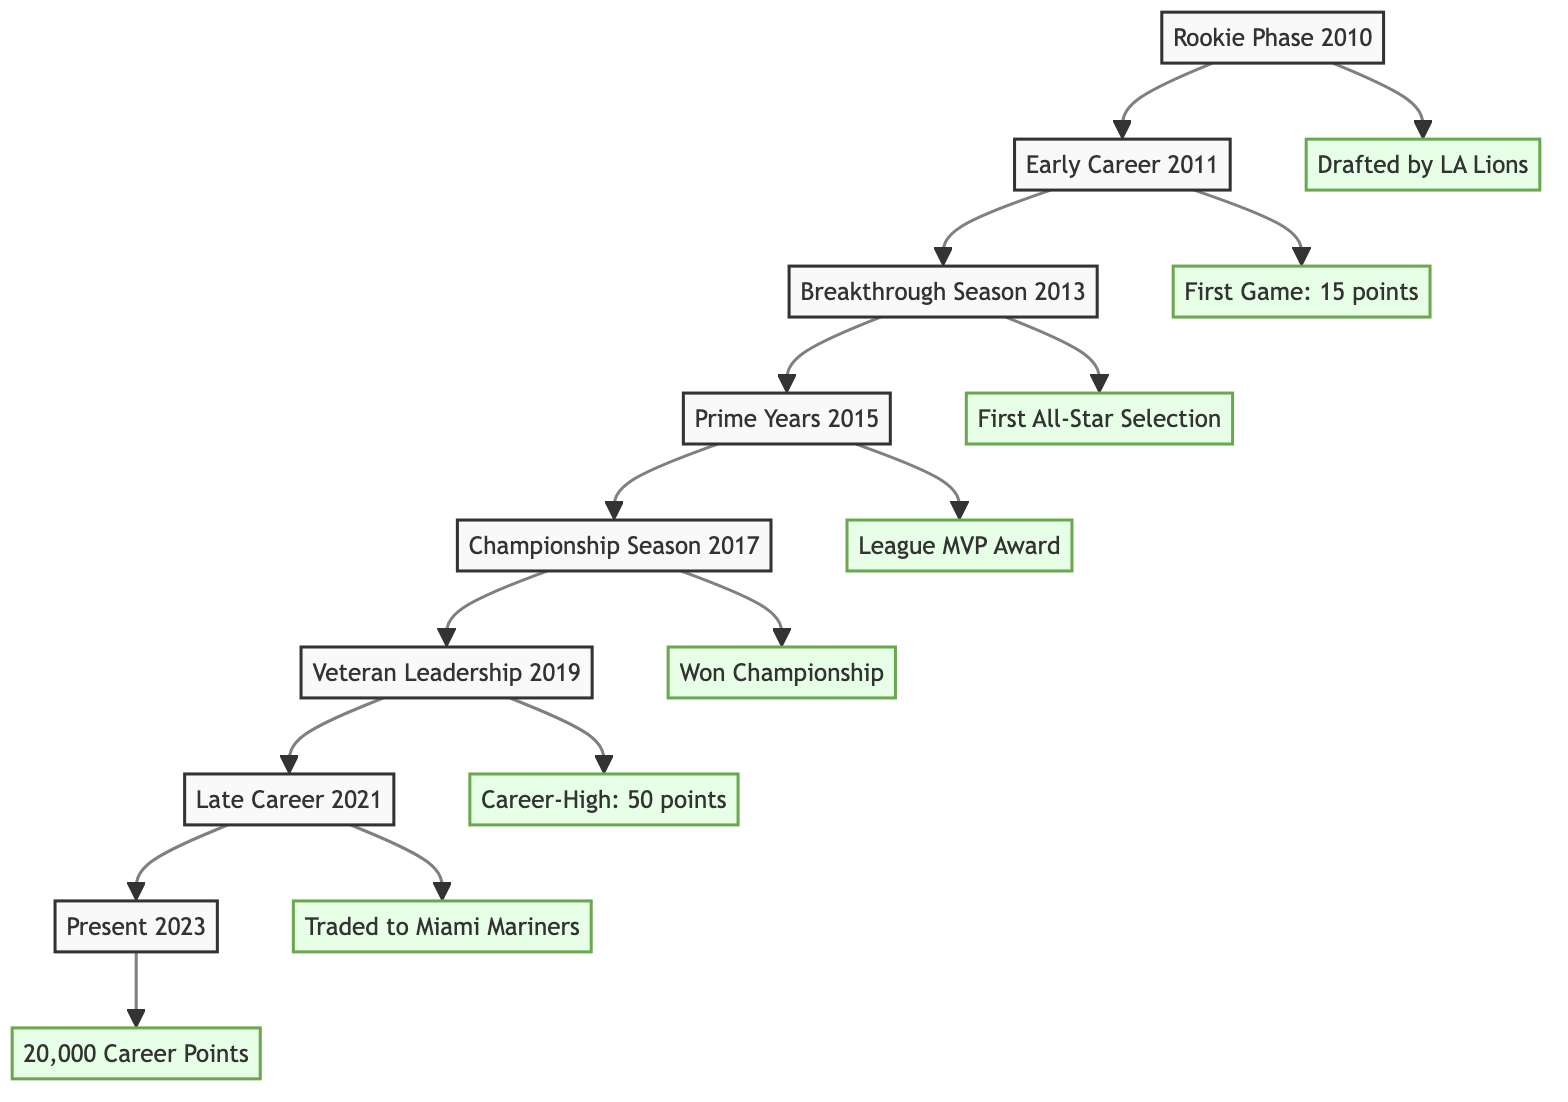What was Rodondo Roach's first professional game? The diagram indicates that Rodondo Roach's first professional game was in 2011. It was against the New York Hawks, where he scored 15 points. This information is found in the "Early Career" section, showing the milestone and the corresponding achievement.
Answer: Debut against New York Hawks; Scored 15 points Which year did Rodondo Roach receive the League MVP Award? Referring to the flow chart, the League MVP Award was achieved during the "Prime Years" stage in 2015. This milestone is directly linked to the specific achievement mentioned in that stage.
Answer: 2015 How many career points did Rodondo Roach surpass by 2023? In the "Present" phase of the flow chart, it is indicated that Rodondo Roach surpassed 20,000 career points in 2023. This conclusion can be drawn directly from the milestone and achievement listed at that node.
Answer: 20,000 career points What significant event occurred in 2017 for Rodondo Roach? The diagram highlights that in 2017, during the "Championship Season," Rodondo Roach won his first championship. This milestone and its achievement can be traced back to the “Championship Season” node within the diagram.
Answer: Won First Championship Which team did Rodondo Roach play for when he was drafted? The flow chart presents that he was drafted by the Los Angeles Lions in 2010 during the "Rookie Phase." This information pertains directly to the initial milestone in his career pathway.
Answer: Los Angeles Lions What was Rodondo Roach's career-high points in a single game? According to the diagram in the "Veteran Leadership" phase for the year 2019, Rodondo Roach scored a career-high of 50 points in a single game against the Chicago Bulldogs. This detail is clearly stated under that specific node.
Answer: 50 points How many major career stages are depicted in the flow chart? The flow chart illustrates a total of 8 stages in Rodondo Roach's career, from Rookie Phase to Present. Each stage represents a distinct period characterized by milestones and achievements. This can be counted directly from the nodes present in the diagram.
Answer: 8 stages What phase marks the beginning of Rodondo Roach's professional career? The flow chart begins with the "Rookie Phase," which is the initial stage of Rodondo Roach's career as indicated in the year 2010. This represents the start of his professional journey in the league.
Answer: Rookie Phase Which milestone is associated with the year 2013? In the diagram, the year 2013 corresponds to the "Breakthrough Season," where Rodondo Roach received his first All-Star selection. This milestone and its associated achievement are specific to that year.
Answer: First All-Star Selection 